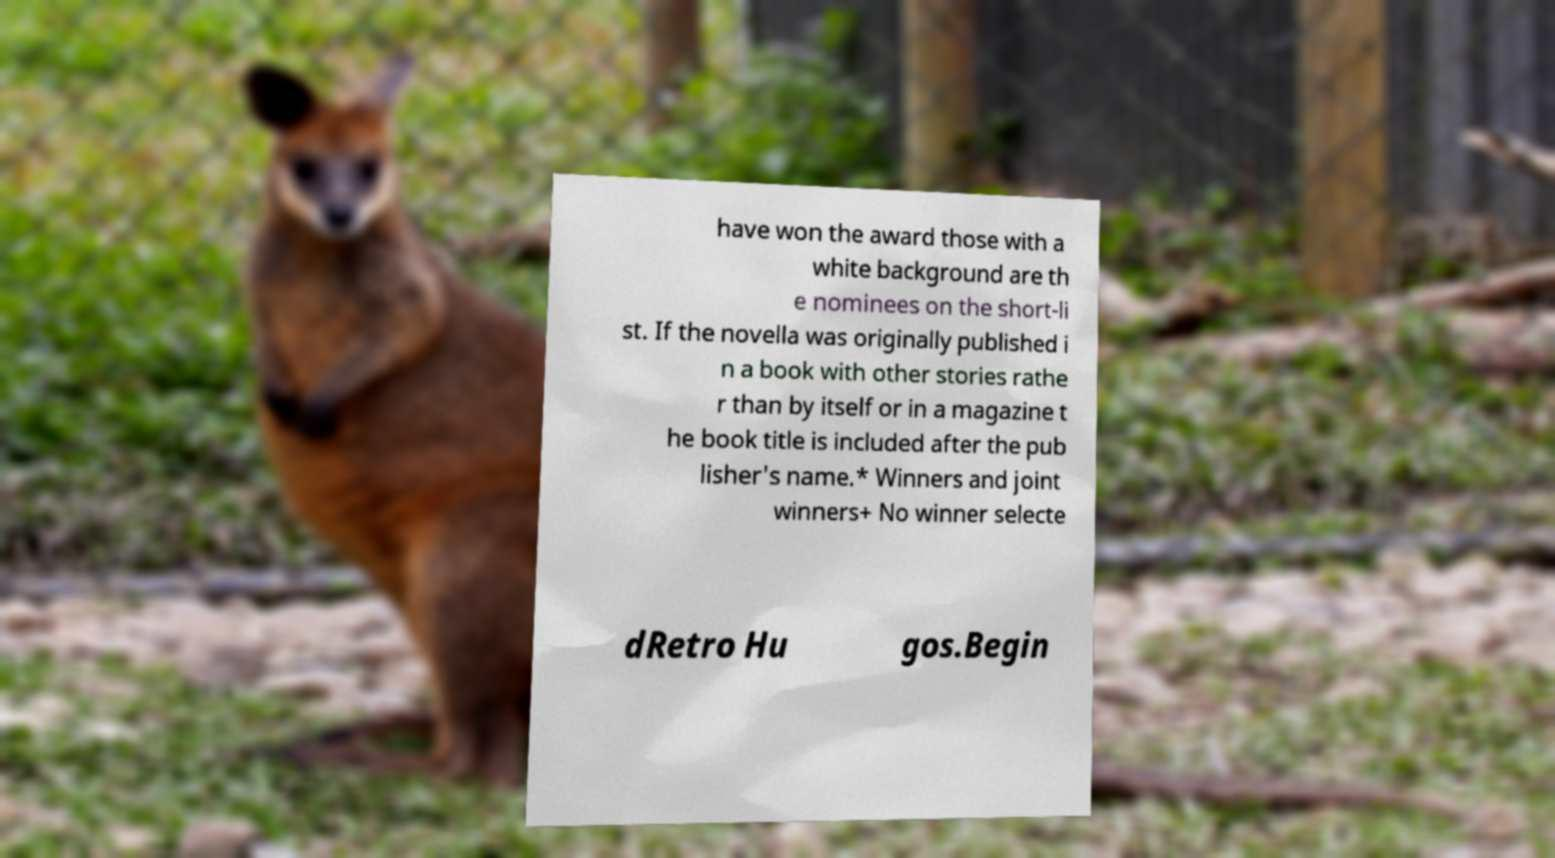There's text embedded in this image that I need extracted. Can you transcribe it verbatim? have won the award those with a white background are th e nominees on the short-li st. If the novella was originally published i n a book with other stories rathe r than by itself or in a magazine t he book title is included after the pub lisher's name.* Winners and joint winners+ No winner selecte dRetro Hu gos.Begin 